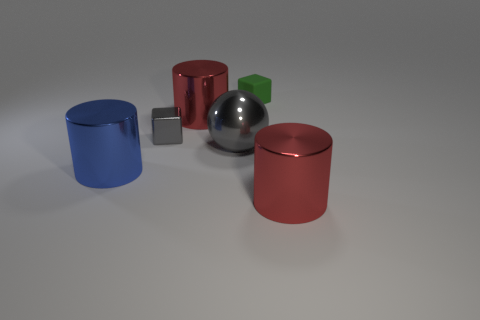There is a gray object that is the same size as the blue cylinder; what material is it?
Your response must be concise. Metal. The small metal cube is what color?
Give a very brief answer. Gray. There is a cylinder that is in front of the big gray object and on the left side of the big metallic sphere; what is its material?
Offer a very short reply. Metal. Is there a large thing behind the large metal sphere that is in front of the red thing that is behind the blue metal cylinder?
Offer a very short reply. Yes. What is the size of the metallic block that is the same color as the large sphere?
Offer a very short reply. Small. Are there any gray shiny cubes behind the small green block?
Your answer should be very brief. No. What number of other things are the same shape as the tiny green rubber object?
Offer a very short reply. 1. There is a sphere that is the same size as the blue shiny thing; what color is it?
Provide a succinct answer. Gray. Are there fewer metal objects that are to the right of the large blue thing than tiny gray blocks behind the tiny green cube?
Offer a very short reply. No. There is a large red shiny object that is behind the red metal cylinder that is in front of the big blue metal cylinder; what number of big metal cylinders are in front of it?
Provide a succinct answer. 2. 